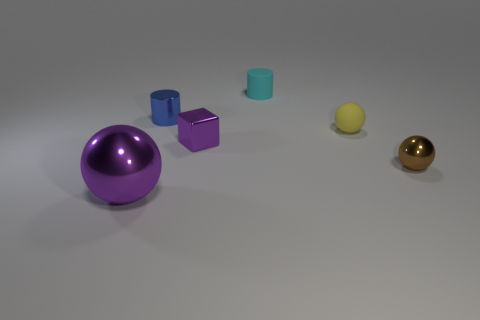Add 1 big gray balls. How many objects exist? 7 Subtract all cylinders. How many objects are left? 4 Subtract all large rubber objects. Subtract all small shiny objects. How many objects are left? 3 Add 5 small things. How many small things are left? 10 Add 6 blocks. How many blocks exist? 7 Subtract 1 yellow spheres. How many objects are left? 5 